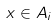<formula> <loc_0><loc_0><loc_500><loc_500>x \in A _ { i }</formula> 